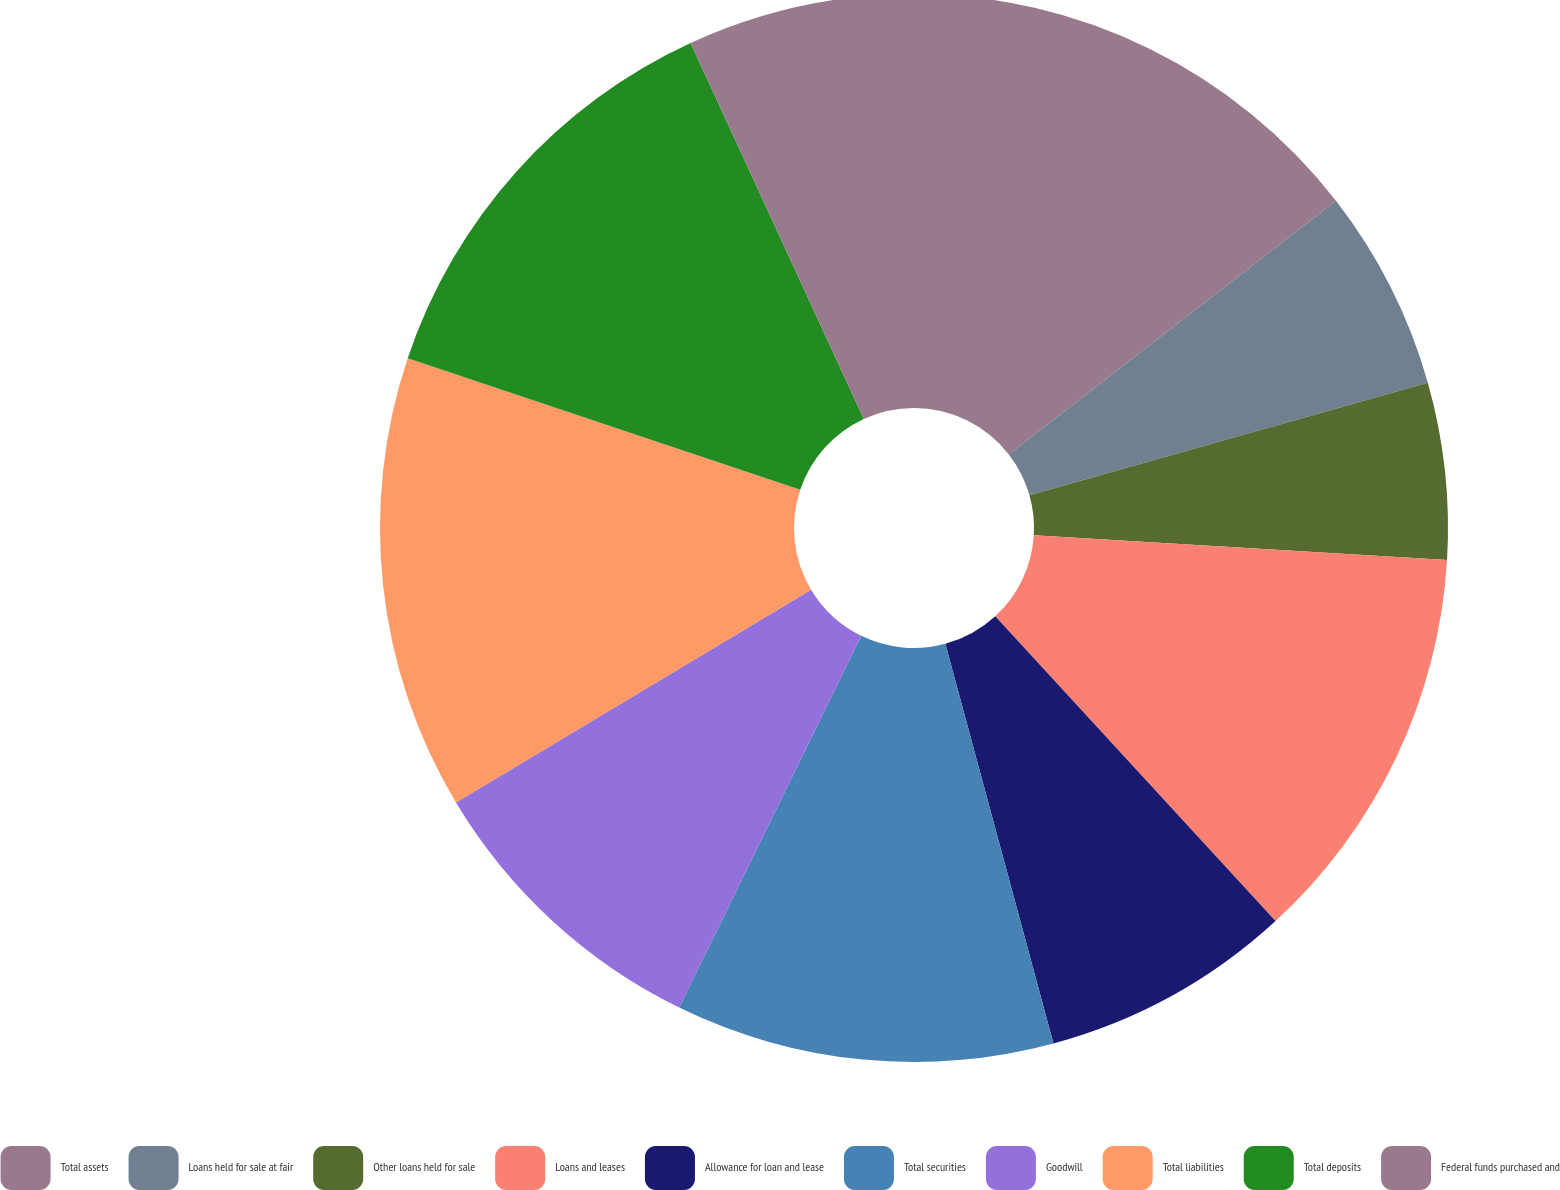Convert chart. <chart><loc_0><loc_0><loc_500><loc_500><pie_chart><fcel>Total assets<fcel>Loans held for sale at fair<fcel>Other loans held for sale<fcel>Loans and leases<fcel>Allowance for loan and lease<fcel>Total securities<fcel>Goodwill<fcel>Total liabilities<fcel>Total deposits<fcel>Federal funds purchased and<nl><fcel>14.5%<fcel>6.11%<fcel>5.34%<fcel>12.21%<fcel>7.63%<fcel>11.45%<fcel>9.16%<fcel>13.74%<fcel>12.98%<fcel>6.87%<nl></chart> 